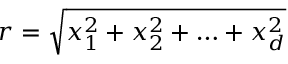Convert formula to latex. <formula><loc_0><loc_0><loc_500><loc_500>r = \sqrt { x _ { 1 } ^ { 2 } + x _ { 2 } ^ { 2 } + \dots + x _ { d } ^ { 2 } }</formula> 